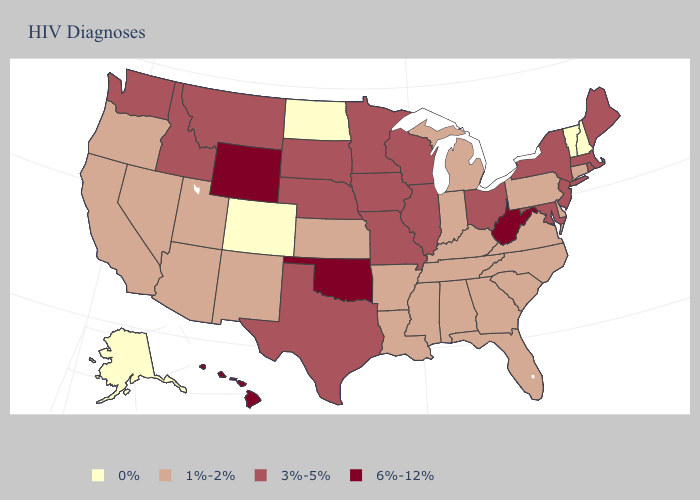Does South Carolina have the same value as Mississippi?
Be succinct. Yes. Which states have the lowest value in the South?
Give a very brief answer. Alabama, Arkansas, Delaware, Florida, Georgia, Kentucky, Louisiana, Mississippi, North Carolina, South Carolina, Tennessee, Virginia. Name the states that have a value in the range 0%?
Write a very short answer. Alaska, Colorado, New Hampshire, North Dakota, Vermont. Name the states that have a value in the range 3%-5%?
Be succinct. Idaho, Illinois, Iowa, Maine, Maryland, Massachusetts, Minnesota, Missouri, Montana, Nebraska, New Jersey, New York, Ohio, Rhode Island, South Dakota, Texas, Washington, Wisconsin. Does Vermont have a higher value than West Virginia?
Give a very brief answer. No. Does Oklahoma have the highest value in the South?
Give a very brief answer. Yes. Does South Dakota have the highest value in the USA?
Write a very short answer. No. Name the states that have a value in the range 1%-2%?
Write a very short answer. Alabama, Arizona, Arkansas, California, Connecticut, Delaware, Florida, Georgia, Indiana, Kansas, Kentucky, Louisiana, Michigan, Mississippi, Nevada, New Mexico, North Carolina, Oregon, Pennsylvania, South Carolina, Tennessee, Utah, Virginia. Name the states that have a value in the range 1%-2%?
Answer briefly. Alabama, Arizona, Arkansas, California, Connecticut, Delaware, Florida, Georgia, Indiana, Kansas, Kentucky, Louisiana, Michigan, Mississippi, Nevada, New Mexico, North Carolina, Oregon, Pennsylvania, South Carolina, Tennessee, Utah, Virginia. Name the states that have a value in the range 1%-2%?
Answer briefly. Alabama, Arizona, Arkansas, California, Connecticut, Delaware, Florida, Georgia, Indiana, Kansas, Kentucky, Louisiana, Michigan, Mississippi, Nevada, New Mexico, North Carolina, Oregon, Pennsylvania, South Carolina, Tennessee, Utah, Virginia. What is the lowest value in states that border Tennessee?
Write a very short answer. 1%-2%. Does New Mexico have the lowest value in the West?
Short answer required. No. What is the lowest value in states that border Rhode Island?
Short answer required. 1%-2%. Name the states that have a value in the range 6%-12%?
Write a very short answer. Hawaii, Oklahoma, West Virginia, Wyoming. What is the value of Virginia?
Write a very short answer. 1%-2%. 